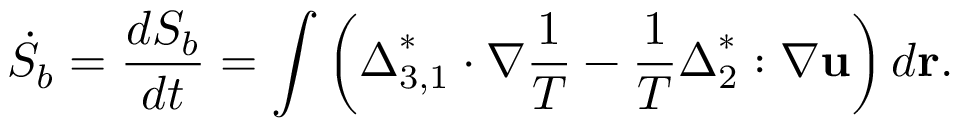Convert formula to latex. <formula><loc_0><loc_0><loc_500><loc_500>{ { \dot { S } } _ { b } } = \frac { { d { S _ { b } } } } { d t } = \int { \left ( { { \Delta } _ { 3 , 1 } ^ { * } \cdot \nabla \frac { 1 } { T } - \frac { 1 } { T } { \Delta } _ { 2 } ^ { * } \colon \nabla { u } } \right ) d { r } } .</formula> 